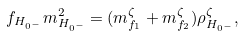Convert formula to latex. <formula><loc_0><loc_0><loc_500><loc_500>f _ { H _ { 0 ^ { - } } } m _ { H _ { 0 ^ { - } } } ^ { 2 } = ( m _ { f _ { 1 } } ^ { \zeta } + m _ { f _ { 2 } } ^ { \zeta } ) \rho _ { H _ { 0 ^ { - } } } ^ { \zeta } ,</formula> 